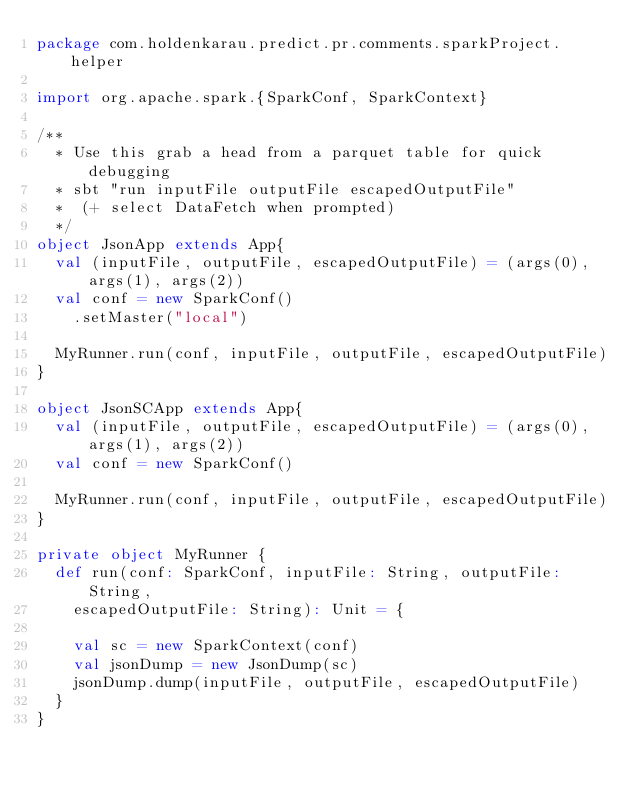<code> <loc_0><loc_0><loc_500><loc_500><_Scala_>package com.holdenkarau.predict.pr.comments.sparkProject.helper

import org.apache.spark.{SparkConf, SparkContext}

/**
  * Use this grab a head from a parquet table for quick debugging
  * sbt "run inputFile outputFile escapedOutputFile"
  *  (+ select DataFetch when prompted)
  */
object JsonApp extends App{
  val (inputFile, outputFile, escapedOutputFile) = (args(0), args(1), args(2))
  val conf = new SparkConf()
    .setMaster("local")

  MyRunner.run(conf, inputFile, outputFile, escapedOutputFile)
}

object JsonSCApp extends App{
  val (inputFile, outputFile, escapedOutputFile) = (args(0), args(1), args(2))
  val conf = new SparkConf()

  MyRunner.run(conf, inputFile, outputFile, escapedOutputFile)
}

private object MyRunner {
  def run(conf: SparkConf, inputFile: String, outputFile: String,
    escapedOutputFile: String): Unit = {

    val sc = new SparkContext(conf)
    val jsonDump = new JsonDump(sc)
    jsonDump.dump(inputFile, outputFile, escapedOutputFile)
  }
}
</code> 